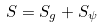Convert formula to latex. <formula><loc_0><loc_0><loc_500><loc_500>S = S _ { g } + S _ { \psi }</formula> 